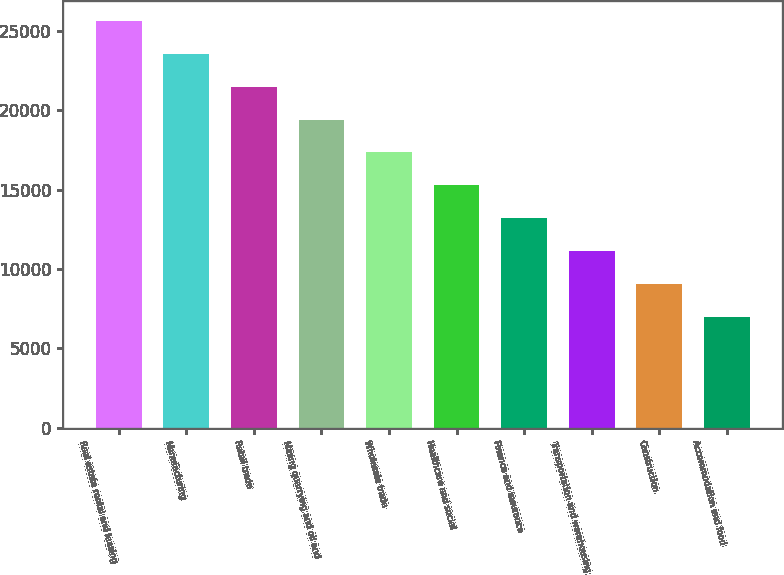Convert chart to OTSL. <chart><loc_0><loc_0><loc_500><loc_500><bar_chart><fcel>Real estate rental and leasing<fcel>Manufacturing<fcel>Retail trade<fcel>Mining quarrying and oil and<fcel>Wholesale trade<fcel>Healthcare and social<fcel>Finance and insurance<fcel>Transportation and warehousing<fcel>Construction<fcel>Accommodation and food<nl><fcel>25619.8<fcel>23549.4<fcel>21479<fcel>19408.6<fcel>17338.2<fcel>15267.8<fcel>13197.4<fcel>11127<fcel>9056.6<fcel>6986.2<nl></chart> 